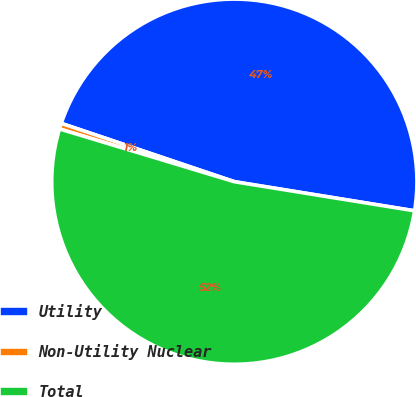Convert chart. <chart><loc_0><loc_0><loc_500><loc_500><pie_chart><fcel>Utility<fcel>Non-Utility Nuclear<fcel>Total<nl><fcel>47.37%<fcel>0.51%<fcel>52.11%<nl></chart> 